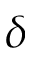Convert formula to latex. <formula><loc_0><loc_0><loc_500><loc_500>\delta</formula> 